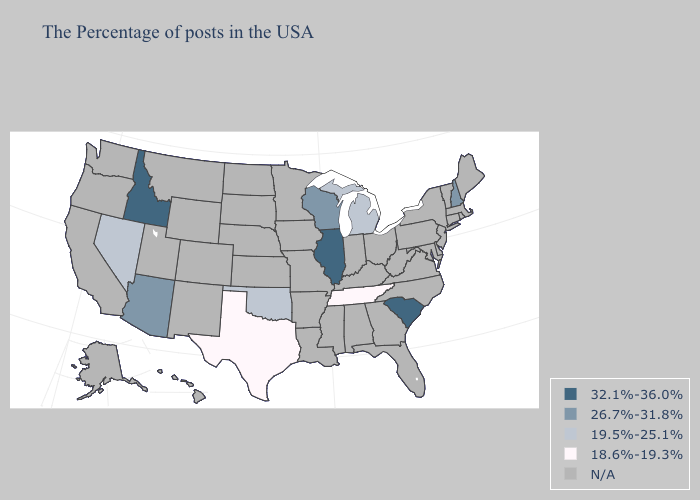What is the lowest value in the Northeast?
Give a very brief answer. 26.7%-31.8%. Name the states that have a value in the range 32.1%-36.0%?
Answer briefly. South Carolina, Illinois, Idaho. What is the lowest value in the South?
Short answer required. 18.6%-19.3%. What is the value of Kansas?
Write a very short answer. N/A. What is the lowest value in the Northeast?
Concise answer only. 26.7%-31.8%. Which states have the lowest value in the MidWest?
Short answer required. Michigan. Name the states that have a value in the range N/A?
Be succinct. Maine, Massachusetts, Rhode Island, Vermont, Connecticut, New York, New Jersey, Delaware, Maryland, Pennsylvania, Virginia, North Carolina, West Virginia, Ohio, Florida, Georgia, Kentucky, Indiana, Alabama, Mississippi, Louisiana, Missouri, Arkansas, Minnesota, Iowa, Kansas, Nebraska, South Dakota, North Dakota, Wyoming, Colorado, New Mexico, Utah, Montana, California, Washington, Oregon, Alaska, Hawaii. Among the states that border Wisconsin , does Michigan have the highest value?
Keep it brief. No. Name the states that have a value in the range N/A?
Answer briefly. Maine, Massachusetts, Rhode Island, Vermont, Connecticut, New York, New Jersey, Delaware, Maryland, Pennsylvania, Virginia, North Carolina, West Virginia, Ohio, Florida, Georgia, Kentucky, Indiana, Alabama, Mississippi, Louisiana, Missouri, Arkansas, Minnesota, Iowa, Kansas, Nebraska, South Dakota, North Dakota, Wyoming, Colorado, New Mexico, Utah, Montana, California, Washington, Oregon, Alaska, Hawaii. What is the value of Arizona?
Answer briefly. 26.7%-31.8%. Name the states that have a value in the range 18.6%-19.3%?
Answer briefly. Tennessee, Texas. Which states have the lowest value in the MidWest?
Give a very brief answer. Michigan. Name the states that have a value in the range 26.7%-31.8%?
Quick response, please. New Hampshire, Wisconsin, Arizona. Name the states that have a value in the range 18.6%-19.3%?
Write a very short answer. Tennessee, Texas. 